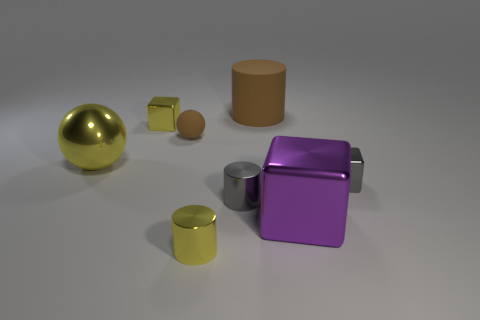Subtract all yellow spheres. Subtract all gray cylinders. How many spheres are left? 1 Add 1 tiny gray things. How many objects exist? 9 Subtract all cubes. How many objects are left? 5 Subtract 0 cyan blocks. How many objects are left? 8 Subtract all large cyan matte spheres. Subtract all large metal balls. How many objects are left? 7 Add 4 balls. How many balls are left? 6 Add 3 metallic cylinders. How many metallic cylinders exist? 5 